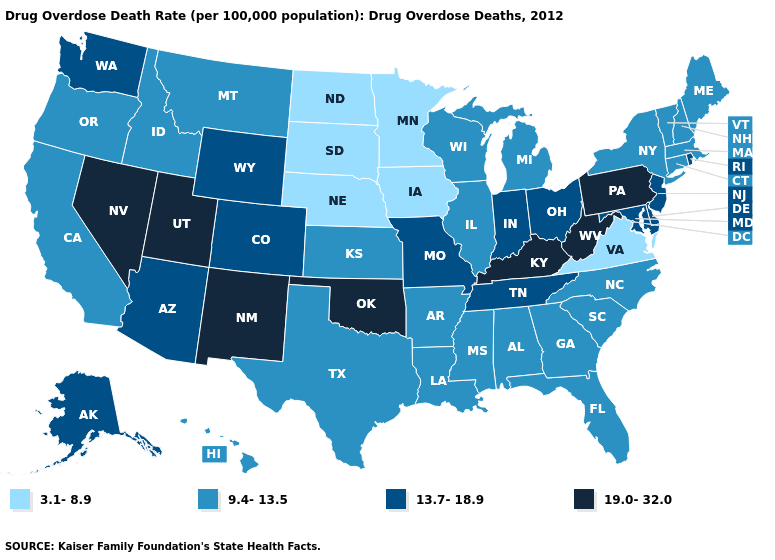Name the states that have a value in the range 3.1-8.9?
Keep it brief. Iowa, Minnesota, Nebraska, North Dakota, South Dakota, Virginia. What is the value of Texas?
Write a very short answer. 9.4-13.5. Name the states that have a value in the range 3.1-8.9?
Concise answer only. Iowa, Minnesota, Nebraska, North Dakota, South Dakota, Virginia. What is the value of Colorado?
Write a very short answer. 13.7-18.9. What is the value of South Dakota?
Short answer required. 3.1-8.9. Which states have the highest value in the USA?
Be succinct. Kentucky, Nevada, New Mexico, Oklahoma, Pennsylvania, Utah, West Virginia. Does Maine have the highest value in the USA?
Quick response, please. No. Name the states that have a value in the range 3.1-8.9?
Concise answer only. Iowa, Minnesota, Nebraska, North Dakota, South Dakota, Virginia. What is the value of Texas?
Write a very short answer. 9.4-13.5. What is the highest value in the USA?
Write a very short answer. 19.0-32.0. Among the states that border North Carolina , does South Carolina have the lowest value?
Answer briefly. No. Is the legend a continuous bar?
Give a very brief answer. No. Does the first symbol in the legend represent the smallest category?
Be succinct. Yes. Name the states that have a value in the range 19.0-32.0?
Answer briefly. Kentucky, Nevada, New Mexico, Oklahoma, Pennsylvania, Utah, West Virginia. 